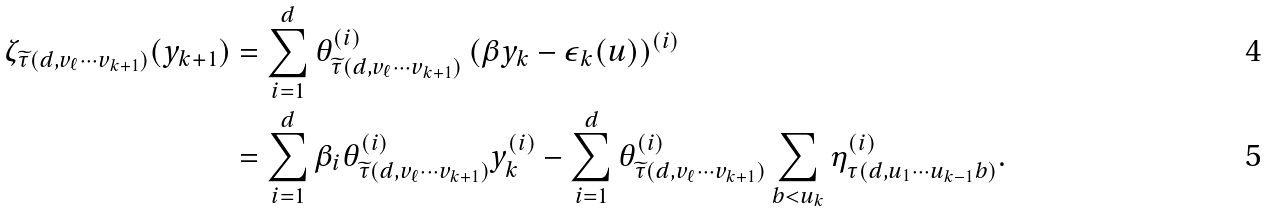Convert formula to latex. <formula><loc_0><loc_0><loc_500><loc_500>\zeta _ { \widetilde { \tau } ( d , v _ { \ell } \cdots v _ { k + 1 } ) } ( y _ { k + 1 } ) & = \sum _ { i = 1 } ^ { d } \theta _ { \widetilde { \tau } ( d , v _ { \ell } \cdots v _ { k + 1 } ) } ^ { ( i ) } \left ( \beta y _ { k } - \epsilon _ { k } ( u ) \right ) ^ { ( i ) } \\ & = \sum _ { i = 1 } ^ { d } \beta _ { i } \theta _ { \widetilde { \tau } ( d , v _ { \ell } \cdots v _ { k + 1 } ) } ^ { ( i ) } y _ { k } ^ { ( i ) } - \sum _ { i = 1 } ^ { d } \theta _ { \widetilde { \tau } ( d , v _ { \ell } \cdots v _ { k + 1 } ) } ^ { ( i ) } \sum _ { b < u _ { k } } \eta _ { \tau ( d , u _ { 1 } \cdots u _ { k - 1 } b ) } ^ { ( i ) } .</formula> 